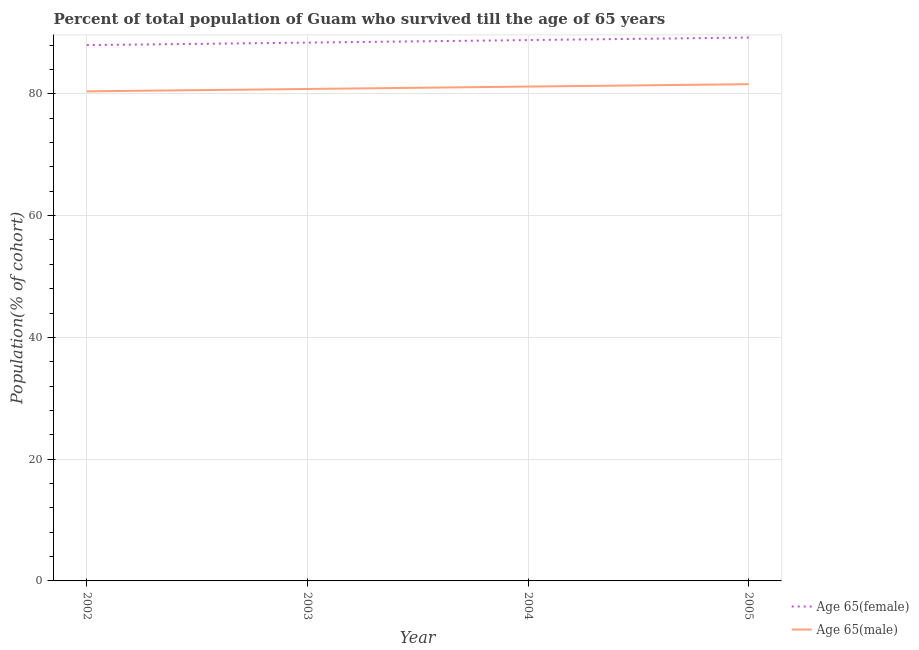Does the line corresponding to percentage of female population who survived till age of 65 intersect with the line corresponding to percentage of male population who survived till age of 65?
Your answer should be compact. No. Is the number of lines equal to the number of legend labels?
Ensure brevity in your answer.  Yes. What is the percentage of male population who survived till age of 65 in 2002?
Your answer should be compact. 80.41. Across all years, what is the maximum percentage of female population who survived till age of 65?
Your answer should be very brief. 89.24. Across all years, what is the minimum percentage of male population who survived till age of 65?
Keep it short and to the point. 80.41. In which year was the percentage of female population who survived till age of 65 maximum?
Make the answer very short. 2005. What is the total percentage of male population who survived till age of 65 in the graph?
Provide a short and direct response. 323.98. What is the difference between the percentage of female population who survived till age of 65 in 2003 and that in 2004?
Your answer should be very brief. -0.41. What is the difference between the percentage of female population who survived till age of 65 in 2004 and the percentage of male population who survived till age of 65 in 2002?
Your answer should be very brief. 8.42. What is the average percentage of female population who survived till age of 65 per year?
Your answer should be very brief. 88.62. In the year 2005, what is the difference between the percentage of female population who survived till age of 65 and percentage of male population who survived till age of 65?
Give a very brief answer. 7.66. What is the ratio of the percentage of female population who survived till age of 65 in 2003 to that in 2004?
Provide a short and direct response. 1. Is the percentage of male population who survived till age of 65 in 2002 less than that in 2004?
Keep it short and to the point. Yes. Is the difference between the percentage of male population who survived till age of 65 in 2002 and 2003 greater than the difference between the percentage of female population who survived till age of 65 in 2002 and 2003?
Make the answer very short. Yes. What is the difference between the highest and the second highest percentage of female population who survived till age of 65?
Your answer should be very brief. 0.41. What is the difference between the highest and the lowest percentage of male population who survived till age of 65?
Make the answer very short. 1.18. In how many years, is the percentage of female population who survived till age of 65 greater than the average percentage of female population who survived till age of 65 taken over all years?
Keep it short and to the point. 2. Is the sum of the percentage of male population who survived till age of 65 in 2003 and 2005 greater than the maximum percentage of female population who survived till age of 65 across all years?
Ensure brevity in your answer.  Yes. Does the percentage of male population who survived till age of 65 monotonically increase over the years?
Give a very brief answer. Yes. Is the percentage of female population who survived till age of 65 strictly less than the percentage of male population who survived till age of 65 over the years?
Make the answer very short. No. How many years are there in the graph?
Offer a very short reply. 4. Are the values on the major ticks of Y-axis written in scientific E-notation?
Your response must be concise. No. What is the title of the graph?
Your answer should be compact. Percent of total population of Guam who survived till the age of 65 years. Does "Male population" appear as one of the legend labels in the graph?
Keep it short and to the point. No. What is the label or title of the X-axis?
Give a very brief answer. Year. What is the label or title of the Y-axis?
Give a very brief answer. Population(% of cohort). What is the Population(% of cohort) in Age 65(female) in 2002?
Ensure brevity in your answer.  88. What is the Population(% of cohort) of Age 65(male) in 2002?
Provide a succinct answer. 80.41. What is the Population(% of cohort) of Age 65(female) in 2003?
Offer a terse response. 88.41. What is the Population(% of cohort) in Age 65(male) in 2003?
Keep it short and to the point. 80.8. What is the Population(% of cohort) in Age 65(female) in 2004?
Offer a terse response. 88.83. What is the Population(% of cohort) of Age 65(male) in 2004?
Give a very brief answer. 81.19. What is the Population(% of cohort) in Age 65(female) in 2005?
Keep it short and to the point. 89.24. What is the Population(% of cohort) of Age 65(male) in 2005?
Provide a succinct answer. 81.58. Across all years, what is the maximum Population(% of cohort) in Age 65(female)?
Your response must be concise. 89.24. Across all years, what is the maximum Population(% of cohort) of Age 65(male)?
Offer a terse response. 81.58. Across all years, what is the minimum Population(% of cohort) of Age 65(female)?
Your response must be concise. 88. Across all years, what is the minimum Population(% of cohort) in Age 65(male)?
Offer a very short reply. 80.41. What is the total Population(% of cohort) of Age 65(female) in the graph?
Make the answer very short. 354.48. What is the total Population(% of cohort) in Age 65(male) in the graph?
Offer a terse response. 323.98. What is the difference between the Population(% of cohort) of Age 65(female) in 2002 and that in 2003?
Your answer should be compact. -0.41. What is the difference between the Population(% of cohort) in Age 65(male) in 2002 and that in 2003?
Offer a terse response. -0.39. What is the difference between the Population(% of cohort) in Age 65(female) in 2002 and that in 2004?
Your answer should be compact. -0.83. What is the difference between the Population(% of cohort) of Age 65(male) in 2002 and that in 2004?
Make the answer very short. -0.78. What is the difference between the Population(% of cohort) in Age 65(female) in 2002 and that in 2005?
Offer a terse response. -1.24. What is the difference between the Population(% of cohort) in Age 65(male) in 2002 and that in 2005?
Ensure brevity in your answer.  -1.18. What is the difference between the Population(% of cohort) of Age 65(female) in 2003 and that in 2004?
Your answer should be very brief. -0.41. What is the difference between the Population(% of cohort) in Age 65(male) in 2003 and that in 2004?
Make the answer very short. -0.39. What is the difference between the Population(% of cohort) of Age 65(female) in 2003 and that in 2005?
Your answer should be compact. -0.83. What is the difference between the Population(% of cohort) in Age 65(male) in 2003 and that in 2005?
Give a very brief answer. -0.78. What is the difference between the Population(% of cohort) of Age 65(female) in 2004 and that in 2005?
Give a very brief answer. -0.41. What is the difference between the Population(% of cohort) in Age 65(male) in 2004 and that in 2005?
Give a very brief answer. -0.39. What is the difference between the Population(% of cohort) of Age 65(female) in 2002 and the Population(% of cohort) of Age 65(male) in 2003?
Your answer should be compact. 7.2. What is the difference between the Population(% of cohort) in Age 65(female) in 2002 and the Population(% of cohort) in Age 65(male) in 2004?
Your answer should be very brief. 6.81. What is the difference between the Population(% of cohort) in Age 65(female) in 2002 and the Population(% of cohort) in Age 65(male) in 2005?
Keep it short and to the point. 6.42. What is the difference between the Population(% of cohort) in Age 65(female) in 2003 and the Population(% of cohort) in Age 65(male) in 2004?
Offer a very short reply. 7.22. What is the difference between the Population(% of cohort) of Age 65(female) in 2003 and the Population(% of cohort) of Age 65(male) in 2005?
Your response must be concise. 6.83. What is the difference between the Population(% of cohort) of Age 65(female) in 2004 and the Population(% of cohort) of Age 65(male) in 2005?
Your response must be concise. 7.24. What is the average Population(% of cohort) in Age 65(female) per year?
Keep it short and to the point. 88.62. What is the average Population(% of cohort) in Age 65(male) per year?
Give a very brief answer. 80.99. In the year 2002, what is the difference between the Population(% of cohort) in Age 65(female) and Population(% of cohort) in Age 65(male)?
Offer a very short reply. 7.59. In the year 2003, what is the difference between the Population(% of cohort) of Age 65(female) and Population(% of cohort) of Age 65(male)?
Your response must be concise. 7.62. In the year 2004, what is the difference between the Population(% of cohort) of Age 65(female) and Population(% of cohort) of Age 65(male)?
Provide a short and direct response. 7.64. In the year 2005, what is the difference between the Population(% of cohort) in Age 65(female) and Population(% of cohort) in Age 65(male)?
Offer a very short reply. 7.66. What is the ratio of the Population(% of cohort) in Age 65(male) in 2002 to that in 2003?
Make the answer very short. 1. What is the ratio of the Population(% of cohort) in Age 65(female) in 2002 to that in 2004?
Offer a very short reply. 0.99. What is the ratio of the Population(% of cohort) in Age 65(male) in 2002 to that in 2004?
Your answer should be very brief. 0.99. What is the ratio of the Population(% of cohort) in Age 65(female) in 2002 to that in 2005?
Keep it short and to the point. 0.99. What is the ratio of the Population(% of cohort) in Age 65(male) in 2002 to that in 2005?
Provide a short and direct response. 0.99. What is the ratio of the Population(% of cohort) of Age 65(female) in 2003 to that in 2004?
Ensure brevity in your answer.  1. What is the ratio of the Population(% of cohort) in Age 65(male) in 2003 to that in 2004?
Keep it short and to the point. 1. What is the ratio of the Population(% of cohort) of Age 65(female) in 2003 to that in 2005?
Your response must be concise. 0.99. What is the ratio of the Population(% of cohort) of Age 65(male) in 2003 to that in 2005?
Your answer should be very brief. 0.99. What is the ratio of the Population(% of cohort) in Age 65(female) in 2004 to that in 2005?
Ensure brevity in your answer.  1. What is the ratio of the Population(% of cohort) in Age 65(male) in 2004 to that in 2005?
Ensure brevity in your answer.  1. What is the difference between the highest and the second highest Population(% of cohort) of Age 65(female)?
Offer a terse response. 0.41. What is the difference between the highest and the second highest Population(% of cohort) in Age 65(male)?
Offer a very short reply. 0.39. What is the difference between the highest and the lowest Population(% of cohort) in Age 65(female)?
Ensure brevity in your answer.  1.24. What is the difference between the highest and the lowest Population(% of cohort) in Age 65(male)?
Your response must be concise. 1.18. 